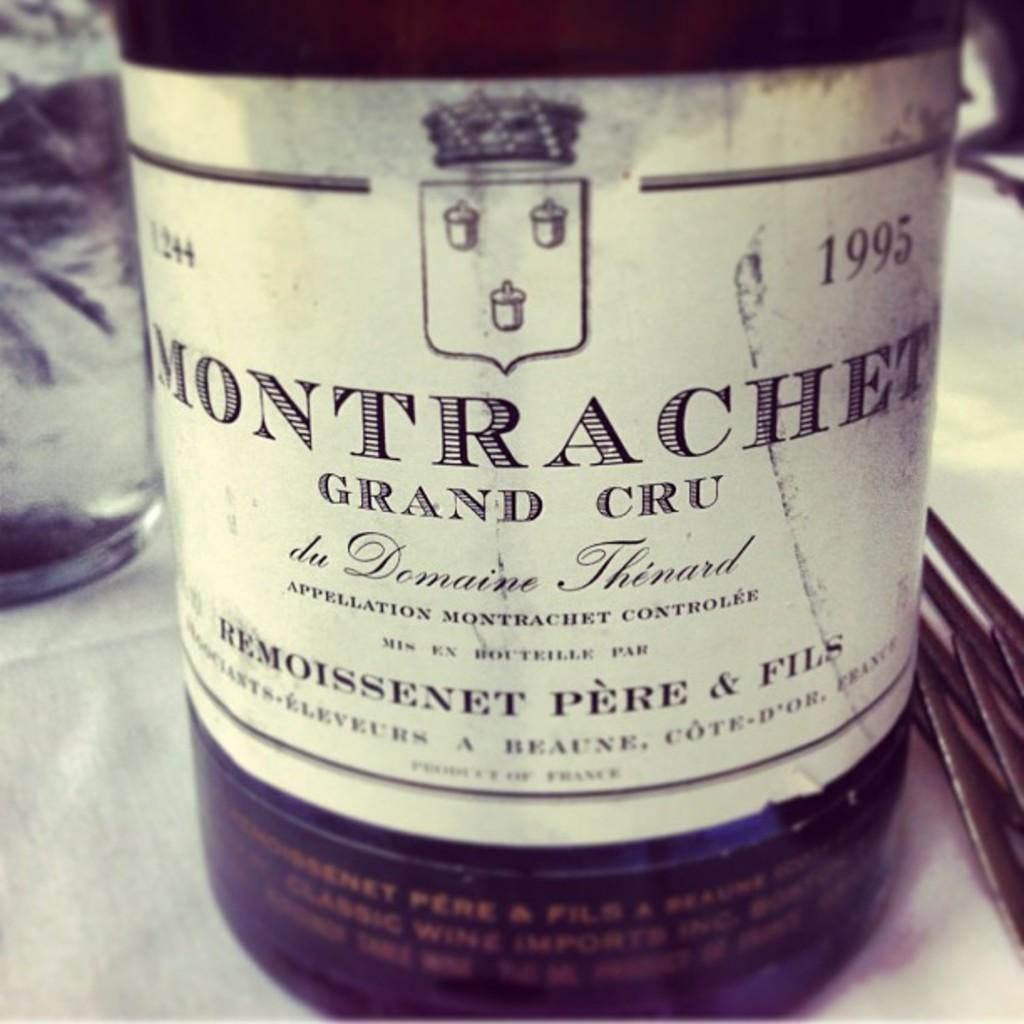<image>
Summarize the visual content of the image. A bottle has the year 1995 on the label. 